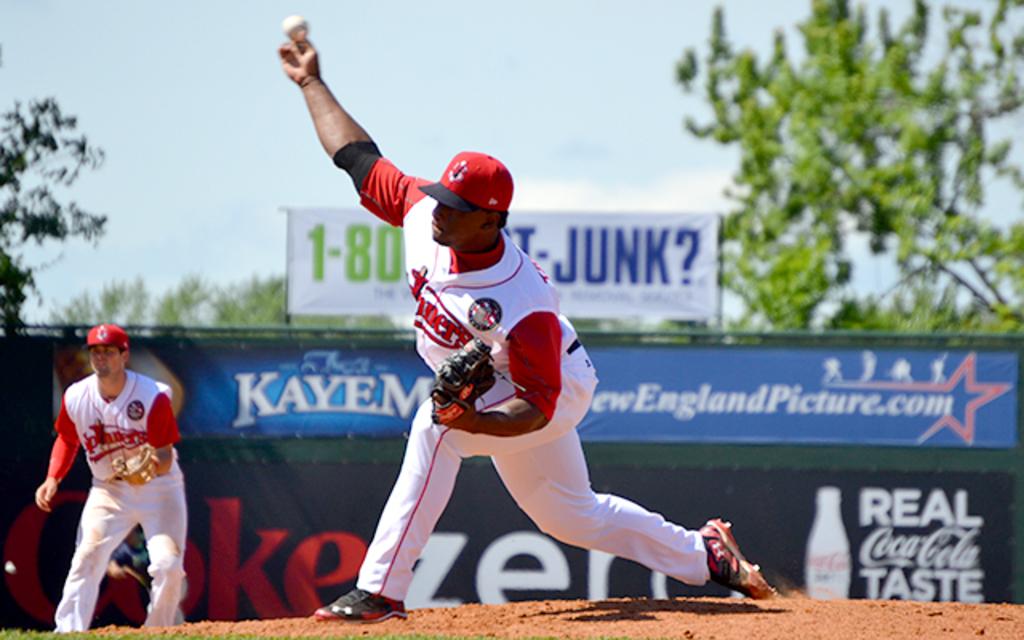What has real coca cola taste?
Give a very brief answer. Coke zero. What is the last word on the banner on the top?
Your answer should be compact. Junk. 